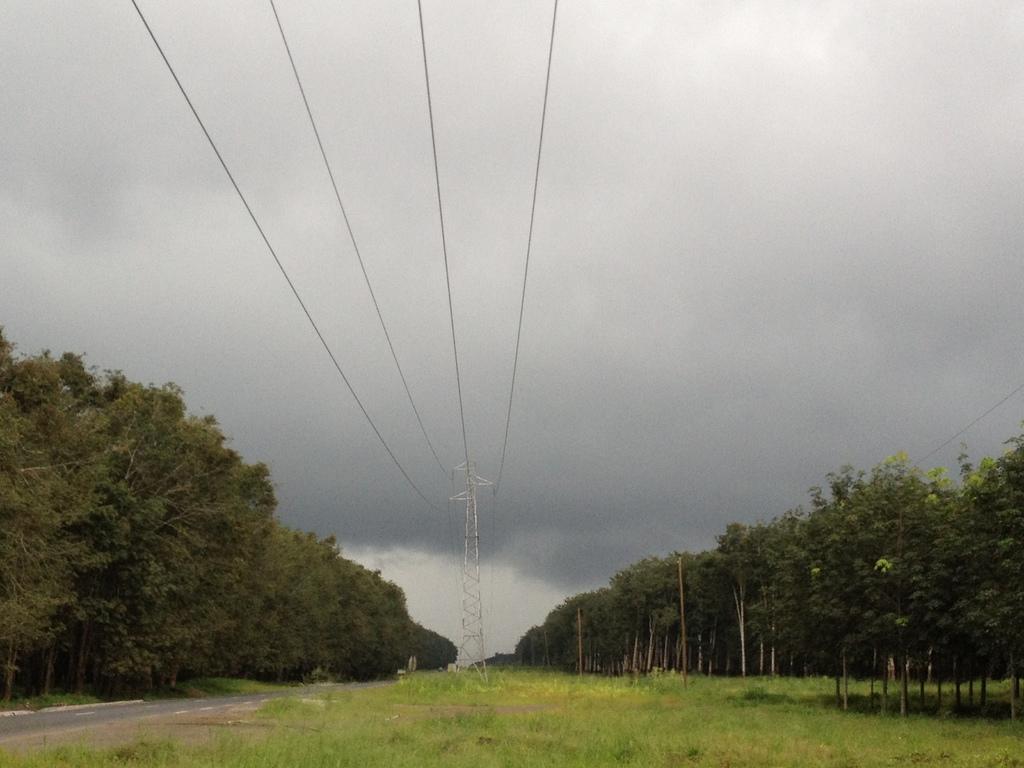Can you describe this image briefly? In this picture we can see a road, beside this road we can see trees, grass, overhead power line and we can see sky in the background. 